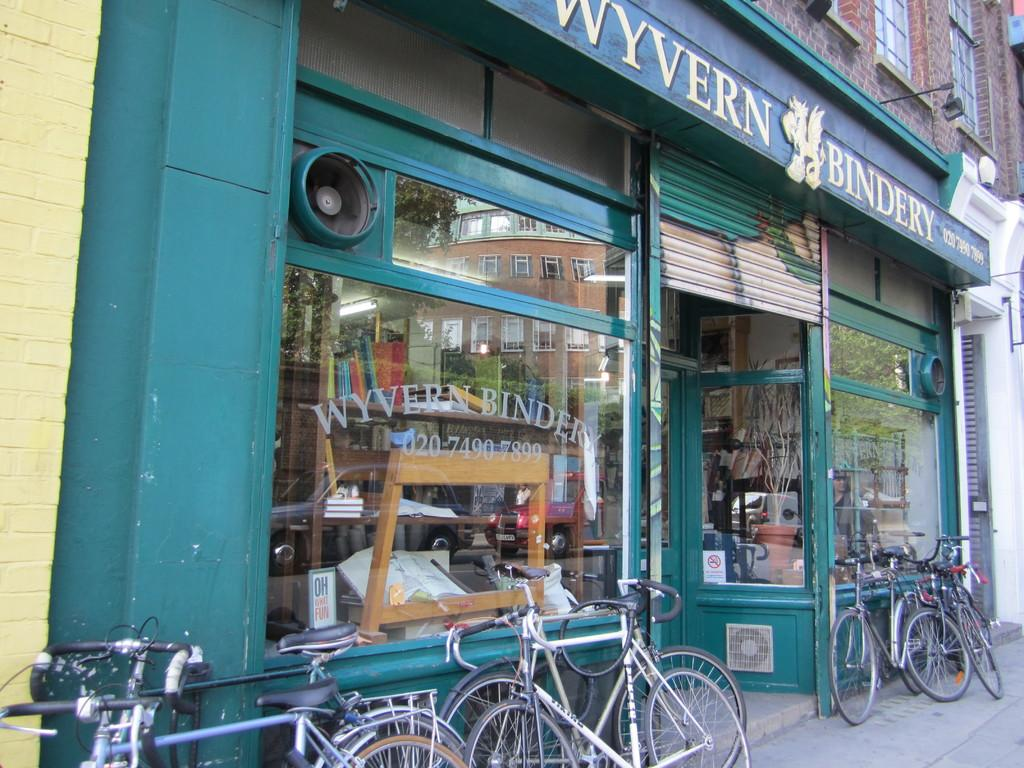<image>
Render a clear and concise summary of the photo. The exterior of a bindery shop in Wyvern has several bycycles resting against it. 